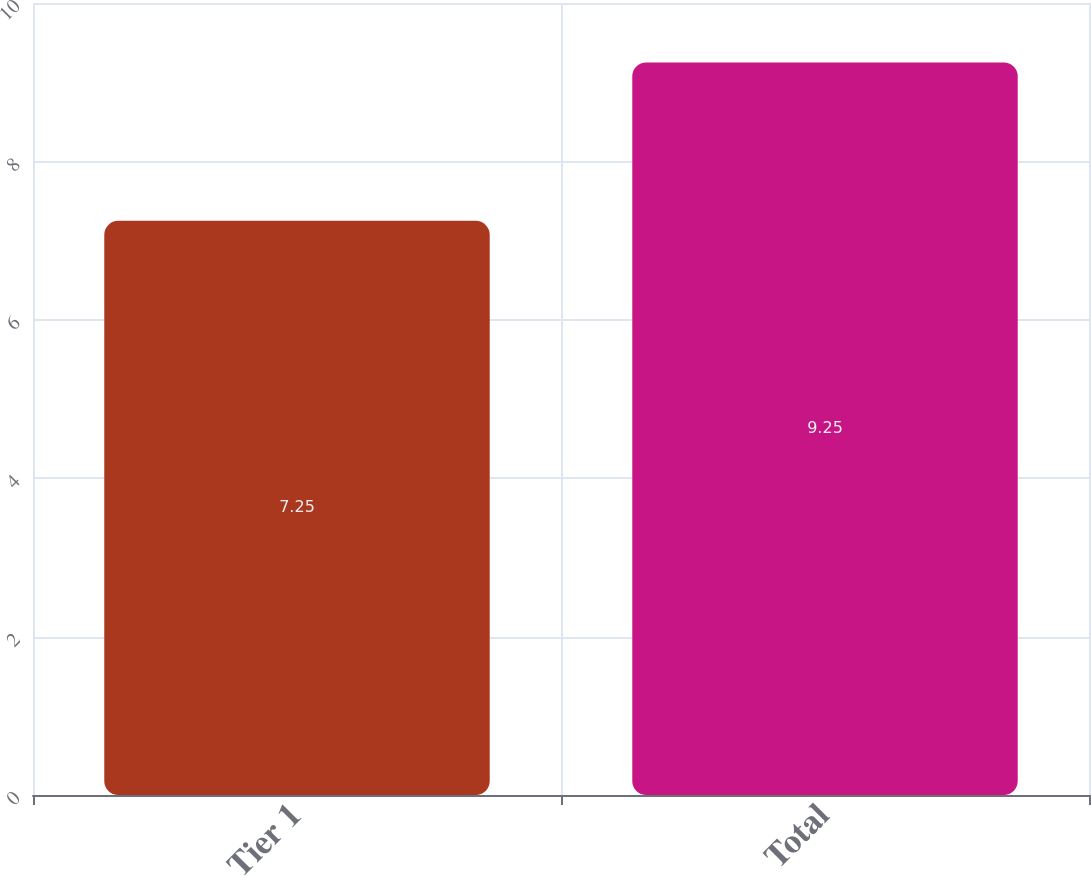Convert chart to OTSL. <chart><loc_0><loc_0><loc_500><loc_500><bar_chart><fcel>Tier 1<fcel>Total<nl><fcel>7.25<fcel>9.25<nl></chart> 